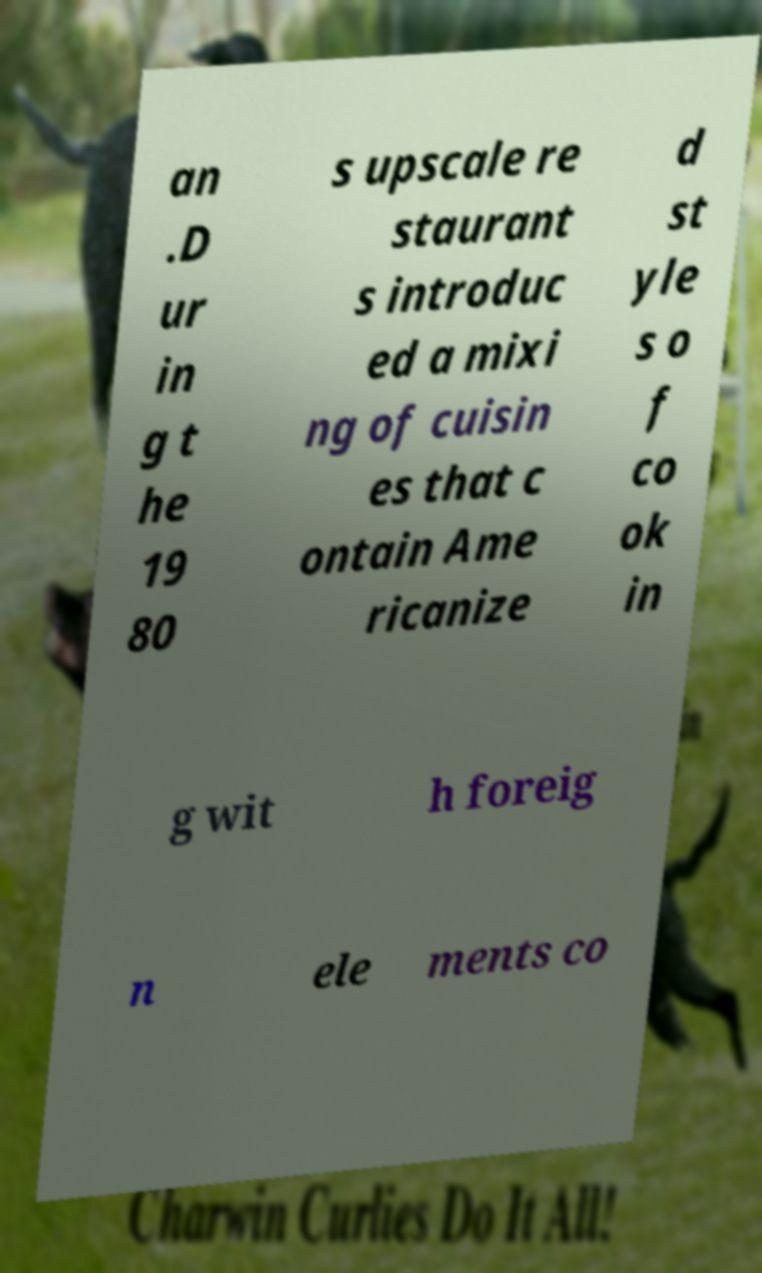Could you extract and type out the text from this image? an .D ur in g t he 19 80 s upscale re staurant s introduc ed a mixi ng of cuisin es that c ontain Ame ricanize d st yle s o f co ok in g wit h foreig n ele ments co 